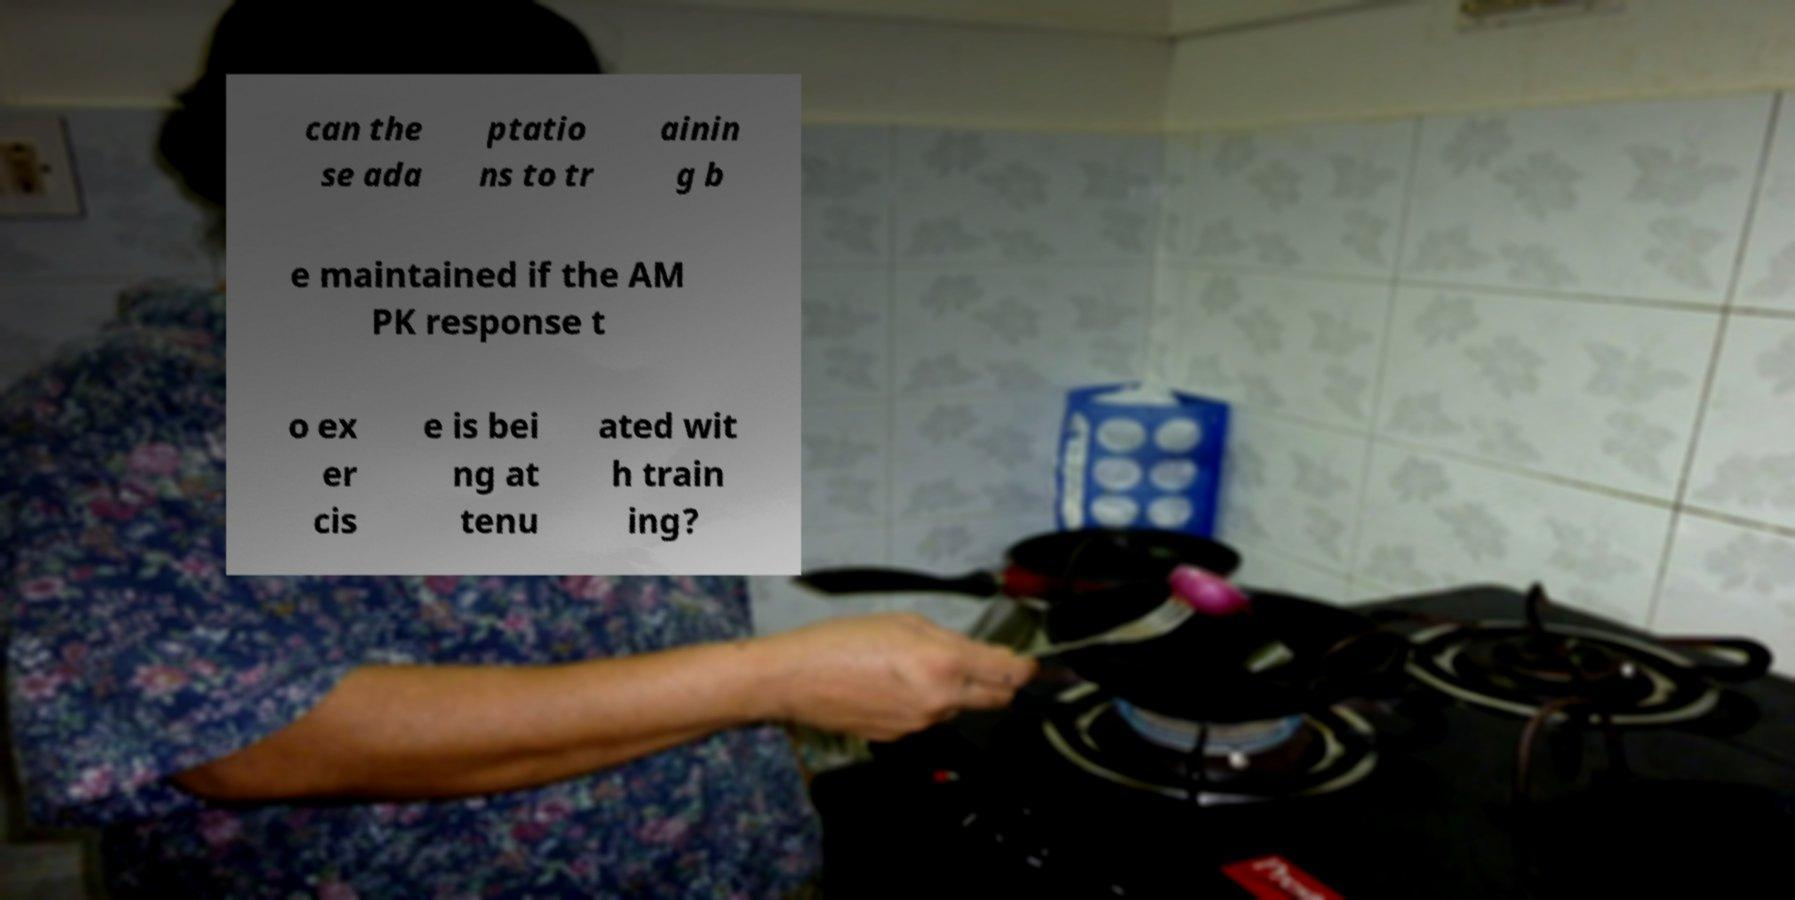Could you extract and type out the text from this image? can the se ada ptatio ns to tr ainin g b e maintained if the AM PK response t o ex er cis e is bei ng at tenu ated wit h train ing? 